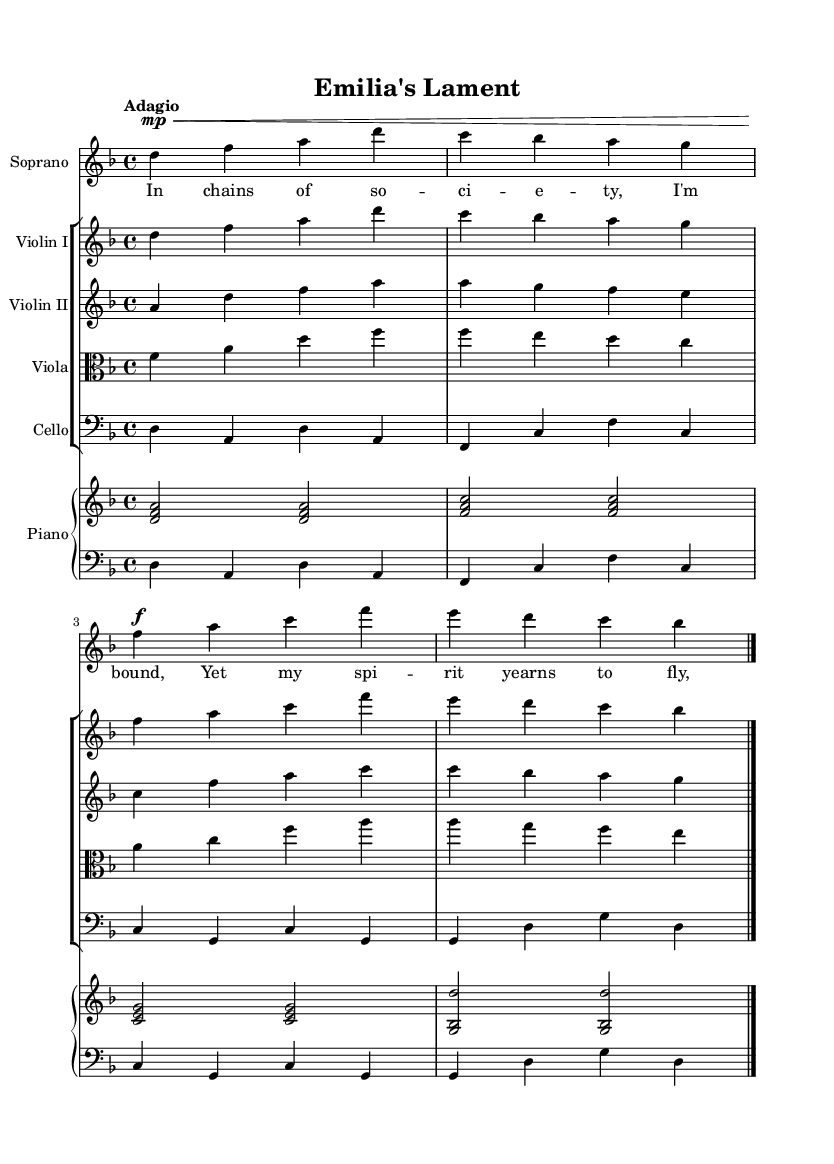What is the key signature of this music? The music is in the key of D minor, which has one flat (B flat). This can be determined from the key signature indicated at the beginning of the staff.
Answer: D minor What is the time signature of this piece? The time signature is indicated as 4/4, which is shown at the beginning of the score. This means there are four beats in a measure, and the quarter note gets one beat.
Answer: 4/4 What is the tempo marking for this music? The tempo marking is "Adagio," which suggests that the piece is to be played slowly. This marking is found at the beginning of the score under the time signature.
Answer: Adagio How many staves are used for the instruments in this piece? The score contains a total of five staves: one for the soprano, one for Violin I, one for Violin II, one for Viola, and one for Cello. This organization can be observed in the layout of the music sheet.
Answer: Five Which instrument has the highest pitch in this arrangement? The soprano has the highest pitch, as indicated by the vocal parts notated on the staff, which is positioned above the string instruments. Additionally, the soprano's notes are generally in a higher range compared to the string instruments.
Answer: Soprano What role does the piano play in this piece? The piano serves as both accompaniment and harmonic support, as indicated by the two staves for the right and left hands, showcasing chords and bass lines. This dual staff format indicates the piano's integral role in supporting the vocal line.
Answer: Accompaniment 